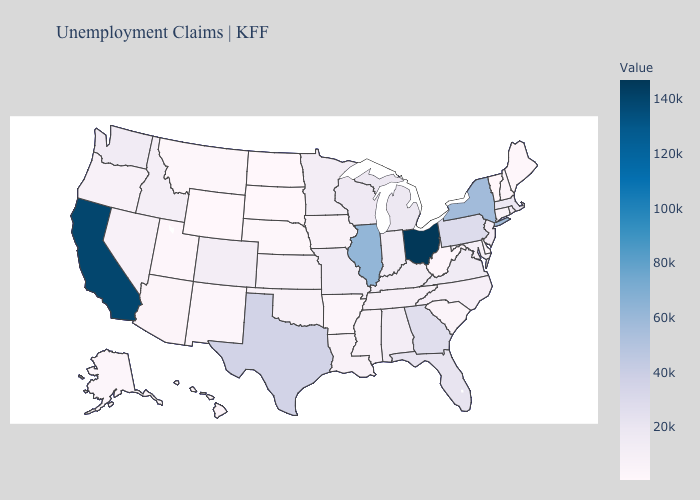Does South Dakota have the lowest value in the USA?
Keep it brief. Yes. 